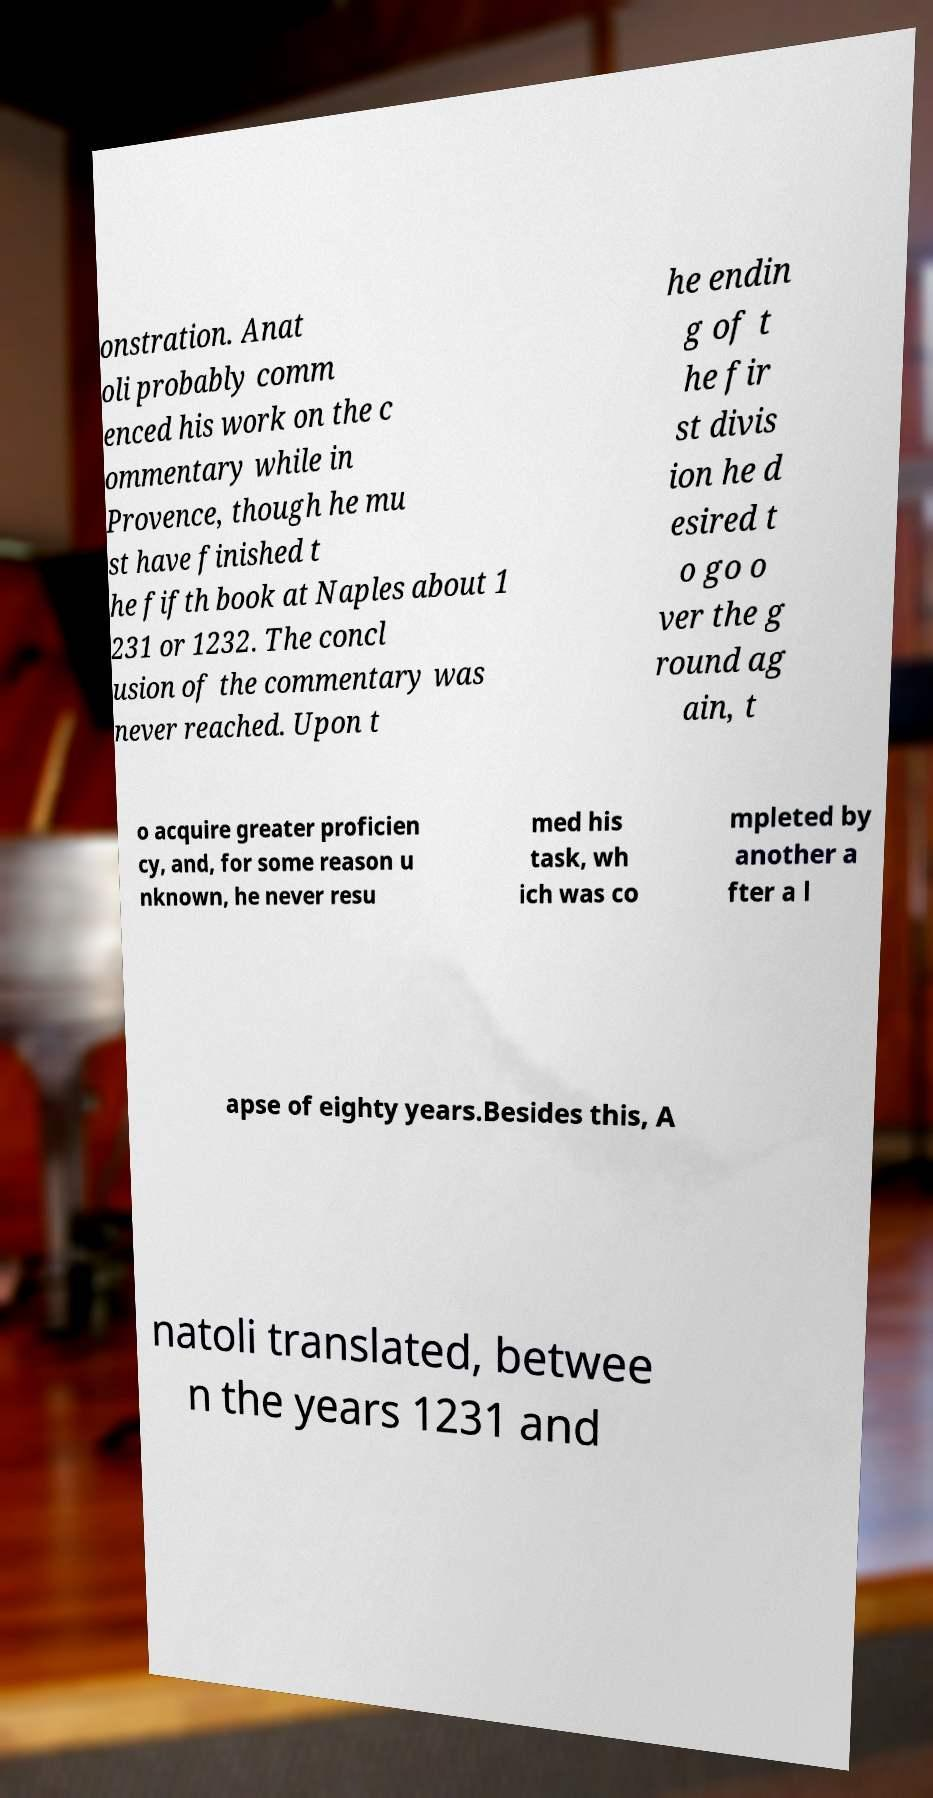There's text embedded in this image that I need extracted. Can you transcribe it verbatim? onstration. Anat oli probably comm enced his work on the c ommentary while in Provence, though he mu st have finished t he fifth book at Naples about 1 231 or 1232. The concl usion of the commentary was never reached. Upon t he endin g of t he fir st divis ion he d esired t o go o ver the g round ag ain, t o acquire greater proficien cy, and, for some reason u nknown, he never resu med his task, wh ich was co mpleted by another a fter a l apse of eighty years.Besides this, A natoli translated, betwee n the years 1231 and 